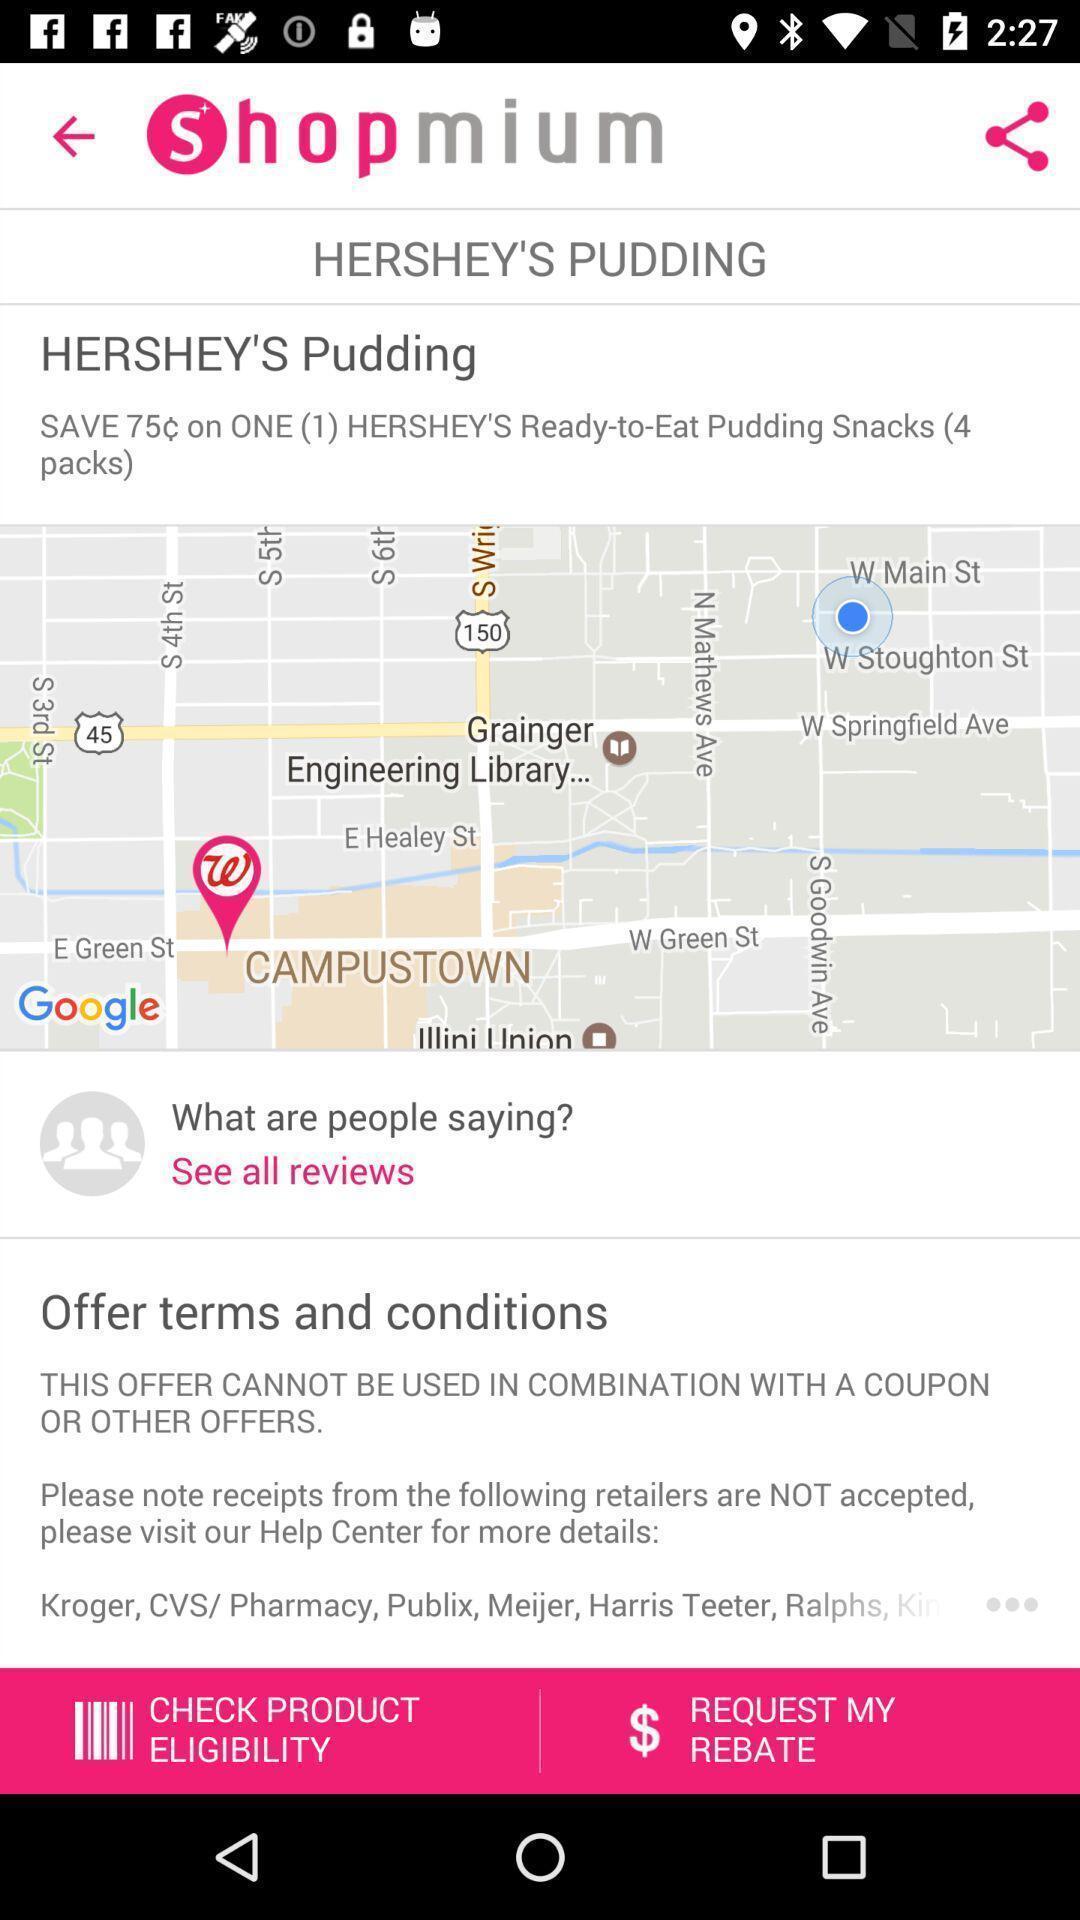Provide a textual representation of this image. Shopping app displayed offer terms and conditions and other options. 